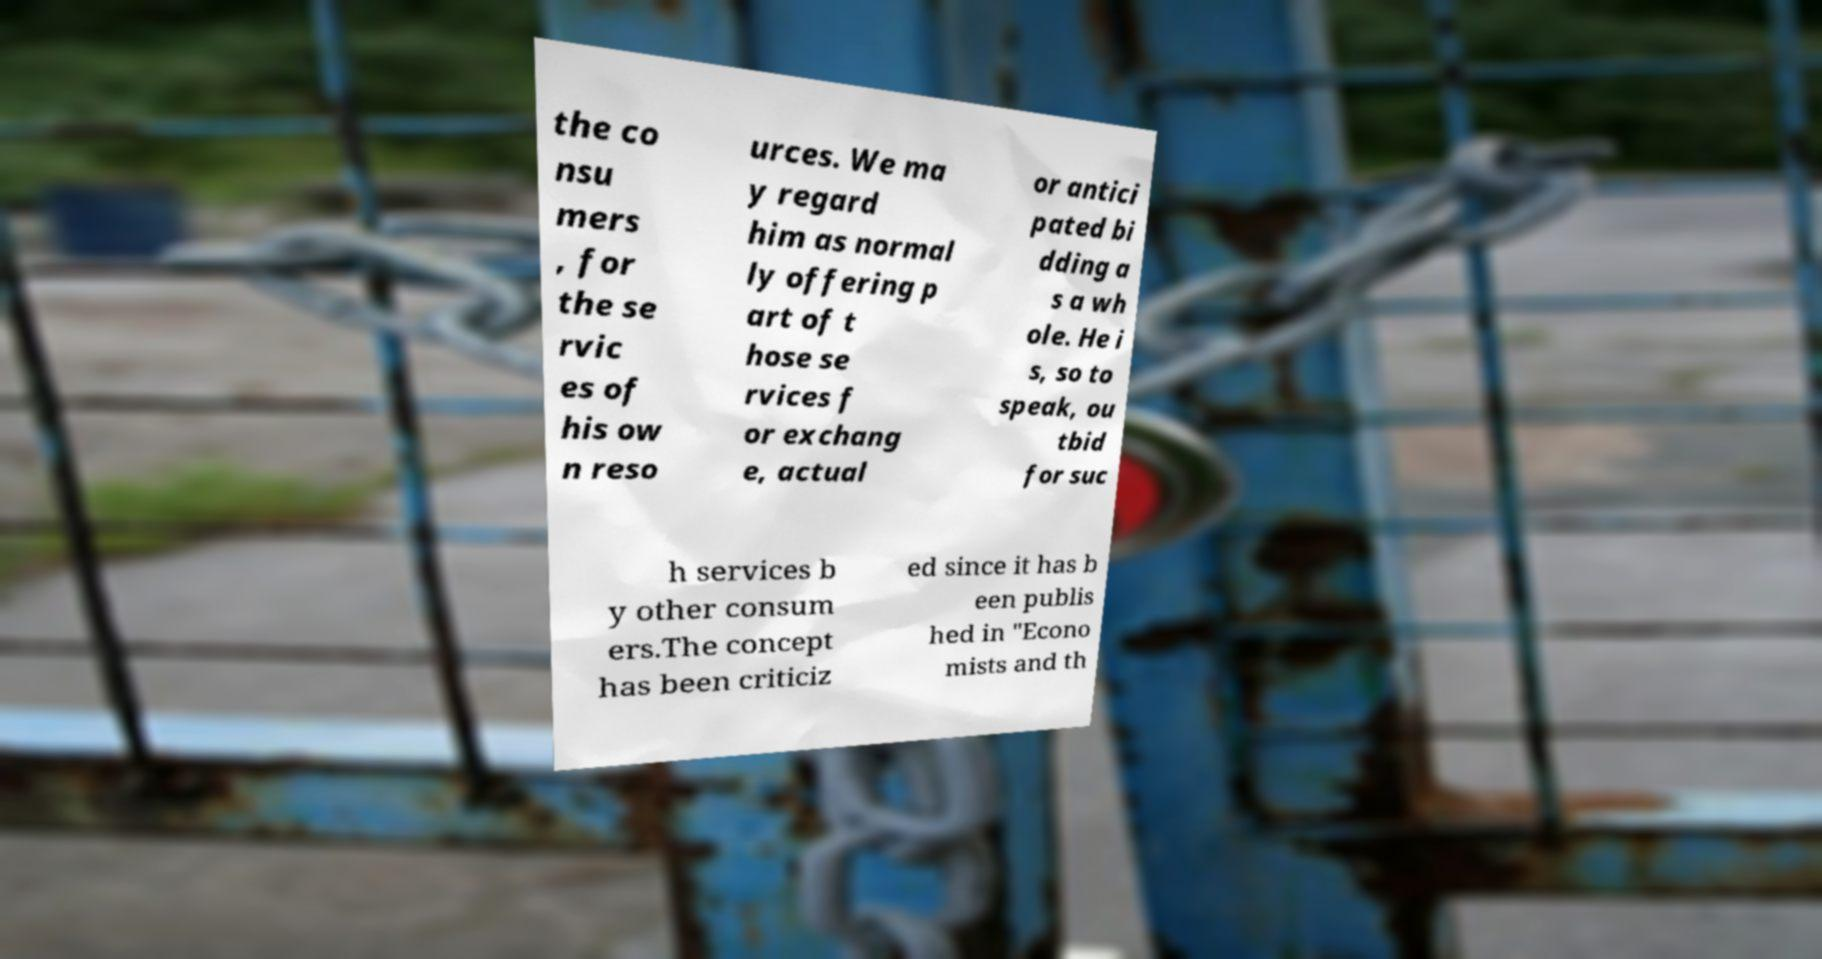Can you read and provide the text displayed in the image?This photo seems to have some interesting text. Can you extract and type it out for me? the co nsu mers , for the se rvic es of his ow n reso urces. We ma y regard him as normal ly offering p art of t hose se rvices f or exchang e, actual or antici pated bi dding a s a wh ole. He i s, so to speak, ou tbid for suc h services b y other consum ers.The concept has been criticiz ed since it has b een publis hed in "Econo mists and th 